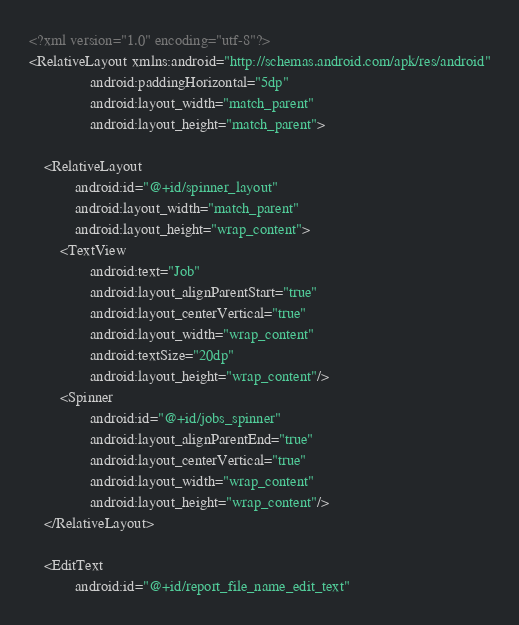Convert code to text. <code><loc_0><loc_0><loc_500><loc_500><_XML_><?xml version="1.0" encoding="utf-8"?>
<RelativeLayout xmlns:android="http://schemas.android.com/apk/res/android"
                android:paddingHorizontal="5dp"
                android:layout_width="match_parent"
                android:layout_height="match_parent">

    <RelativeLayout
            android:id="@+id/spinner_layout"
            android:layout_width="match_parent"
            android:layout_height="wrap_content">
        <TextView
                android:text="Job"
                android:layout_alignParentStart="true"
                android:layout_centerVertical="true"
                android:layout_width="wrap_content"
                android:textSize="20dp"
                android:layout_height="wrap_content"/>
        <Spinner
                android:id="@+id/jobs_spinner"
                android:layout_alignParentEnd="true"
                android:layout_centerVertical="true"
                android:layout_width="wrap_content"
                android:layout_height="wrap_content"/>
    </RelativeLayout>

    <EditText
            android:id="@+id/report_file_name_edit_text"</code> 